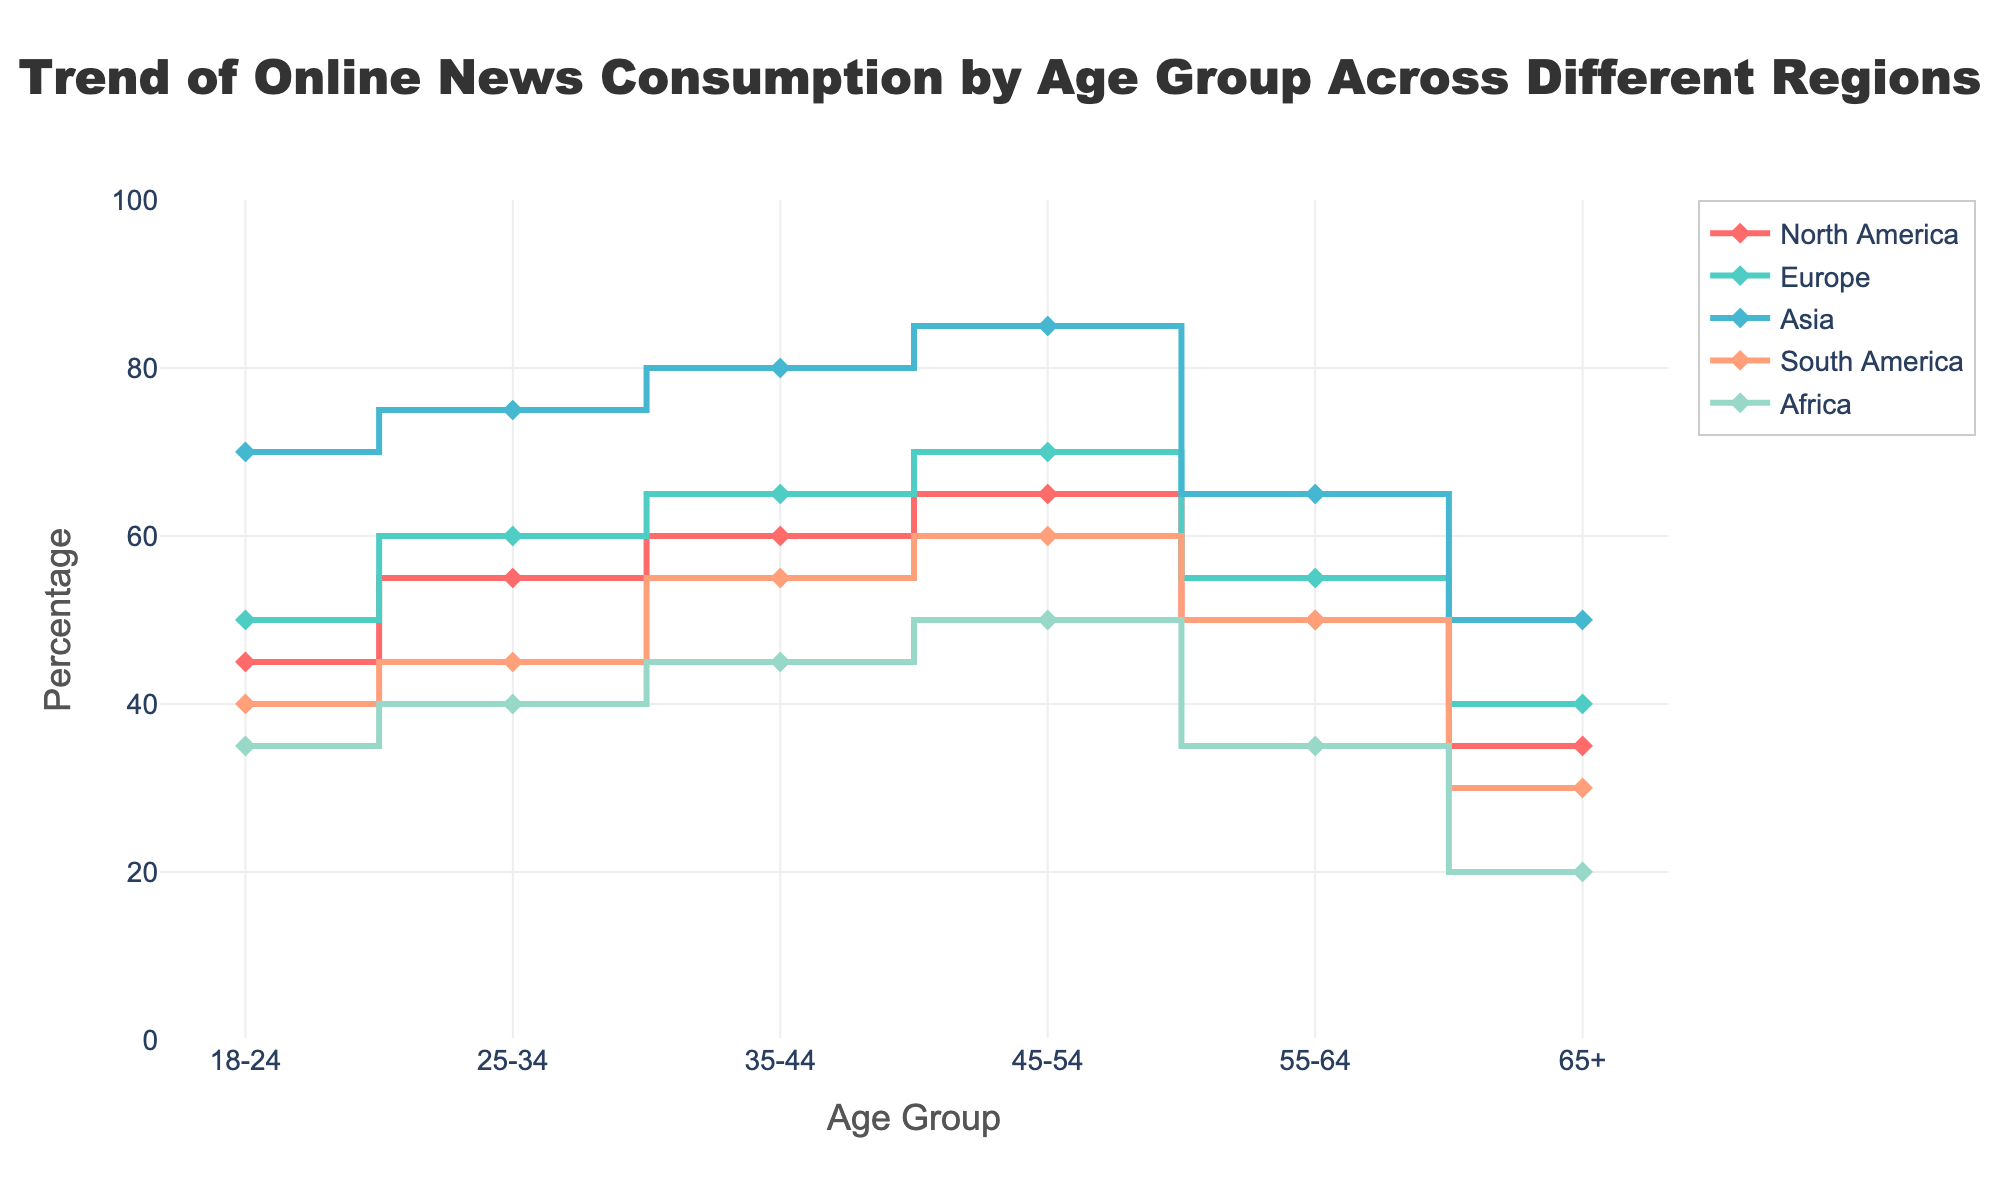What's the title of the plot? The title of the plot is typically found at the top center of the figure. This particular figure has a clear title indicating the subject matter.
Answer: Trend of Online News Consumption by Age Group Across Different Regions Which age group in Asia has the highest percentage of online news consumption? To determine the highest percentage in Asia, locate the section of the plot for Asia and identify the age group with the highest data point.
Answer: 45-54 What is the percentage of online news consumption for the age group 25-34 in Europe? Find the line corresponding to Europe, and then locate the data point specifically for the age group 25-34.
Answer: 60 Compare the 35-44 age group between North America and Asia. Which has a higher percentage? Compare the data point for 35-44 in North America with that in Asia. Identify the higher value between the two.
Answer: Asia By how much does the online news consumption percentage increase from the age group 18-24 to 45-54 in North America? Look at the data points for age groups 18-24 and 45-54 in North America. Subtract the percentage value for 18-24 from that of 45-54.
Answer: 20 What is the trend of online news consumption as age increases in Africa? Examine the line corresponding to Africa and observe the direction of change in percentages as age increases from 18-24 to 65+.
Answer: Decreasing What's the average percentage of online news consumption for age groups in South America? Calculate the average by adding percentages for all age groups in South America and dividing by the number of age groups (6).
Answer: 46 Identify the region with the lowest online news consumption for the 65+ age group. Look at the data points for the 65+ age group across all regions and identify the lowest value.
Answer: Africa Which region shows the most significant decrease in online news consumption from the 55-64 age group to the 65+ age group? Analyze the percentage drop between 55-64 and 65+ for each region and identify the one with the greatest decrease.
Answer: North America 